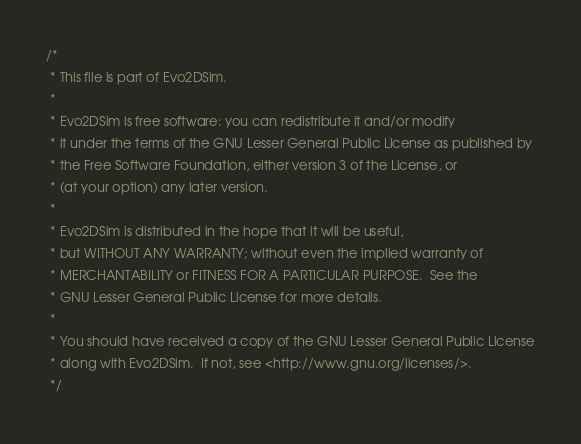Convert code to text. <code><loc_0><loc_0><loc_500><loc_500><_Scala_>/*
 * This file is part of Evo2DSim.
 *
 * Evo2DSim is free software: you can redistribute it and/or modify
 * it under the terms of the GNU Lesser General Public License as published by
 * the Free Software Foundation, either version 3 of the License, or
 * (at your option) any later version.
 *
 * Evo2DSim is distributed in the hope that it will be useful,
 * but WITHOUT ANY WARRANTY; without even the implied warranty of
 * MERCHANTABILITY or FITNESS FOR A PARTICULAR PURPOSE.  See the
 * GNU Lesser General Public License for more details.
 *
 * You should have received a copy of the GNU Lesser General Public License
 * along with Evo2DSim.  If not, see <http://www.gnu.org/licenses/>.
 */
</code> 